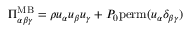<formula> <loc_0><loc_0><loc_500><loc_500>\Pi _ { \alpha \beta \gamma } ^ { M B } = \rho u _ { \alpha } u _ { \beta } u _ { \gamma } + P _ { 0 } p e r m ( u _ { \alpha } \delta _ { \beta \gamma } )</formula> 